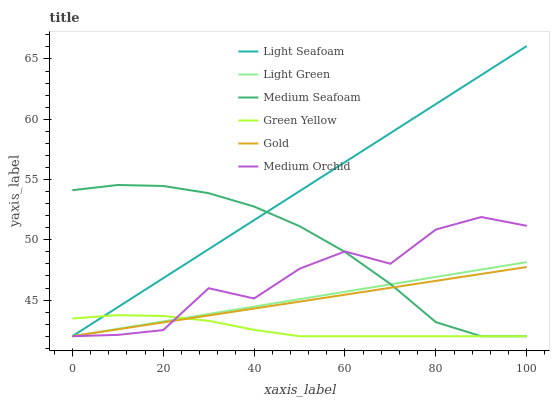Does Green Yellow have the minimum area under the curve?
Answer yes or no. Yes. Does Light Seafoam have the maximum area under the curve?
Answer yes or no. Yes. Does Gold have the minimum area under the curve?
Answer yes or no. No. Does Gold have the maximum area under the curve?
Answer yes or no. No. Is Gold the smoothest?
Answer yes or no. Yes. Is Medium Orchid the roughest?
Answer yes or no. Yes. Is Medium Orchid the smoothest?
Answer yes or no. No. Is Gold the roughest?
Answer yes or no. No. Does Light Seafoam have the highest value?
Answer yes or no. Yes. Does Gold have the highest value?
Answer yes or no. No. Does Green Yellow intersect Medium Seafoam?
Answer yes or no. Yes. Is Green Yellow less than Medium Seafoam?
Answer yes or no. No. Is Green Yellow greater than Medium Seafoam?
Answer yes or no. No. 